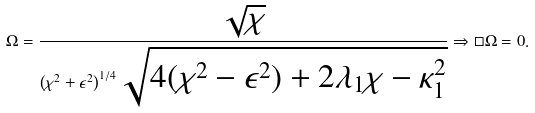<formula> <loc_0><loc_0><loc_500><loc_500>\Omega = \frac { \sqrt { \chi } } { \left ( \chi ^ { 2 } + \epsilon ^ { 2 } \right ) ^ { 1 / 4 } \sqrt { 4 ( \chi ^ { 2 } - \epsilon ^ { 2 } ) + 2 \lambda _ { 1 } \chi - \kappa _ { 1 } ^ { 2 } } } \Rightarrow \Box \Omega = 0 .</formula> 